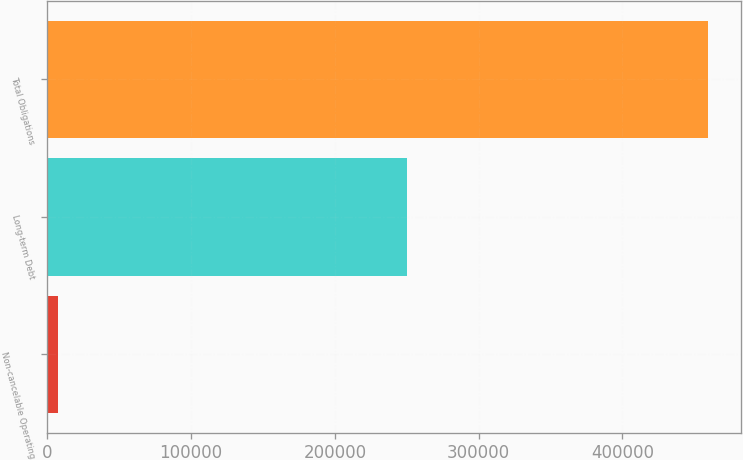Convert chart. <chart><loc_0><loc_0><loc_500><loc_500><bar_chart><fcel>Non-cancelable Operating<fcel>Long-term Debt<fcel>Total Obligations<nl><fcel>7551<fcel>250071<fcel>459322<nl></chart> 